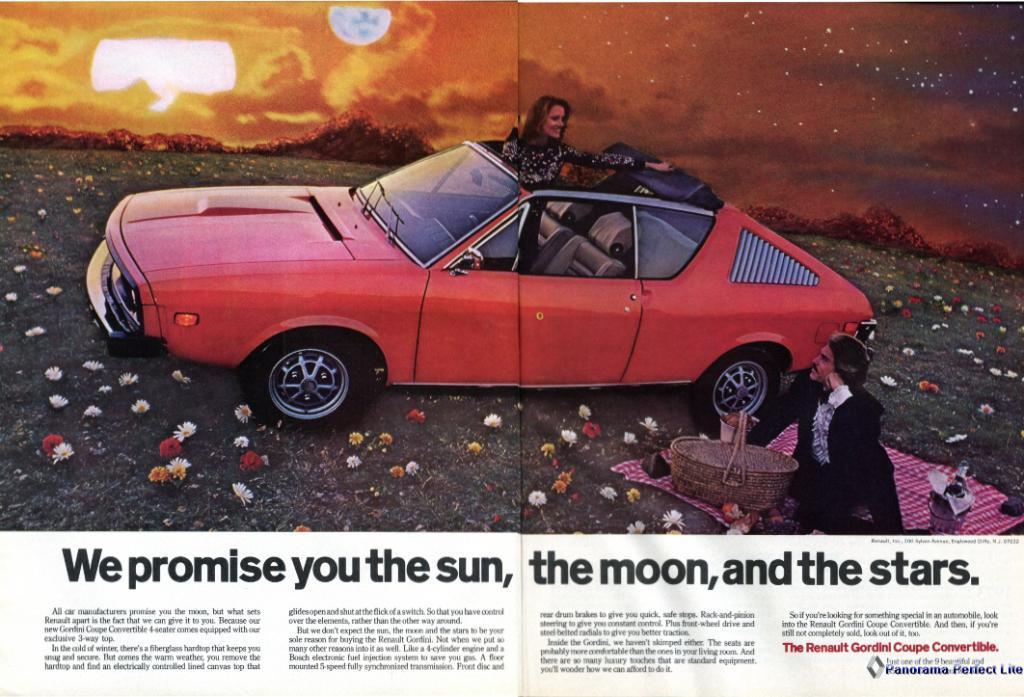Can you describe this image briefly? in this image there is a person sitting in the grass. there is a person next to him. behind him there is a red color car on which a person is present. on the grass there are many colorful flowers. 